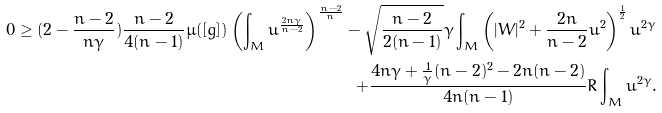Convert formula to latex. <formula><loc_0><loc_0><loc_500><loc_500>0 \geq ( 2 - \frac { n - 2 } { n \gamma } ) \frac { n - 2 } { 4 ( n - 1 ) } \mu ( [ g ] ) \left ( \int _ { M } u ^ { \frac { 2 n \gamma } { n - 2 } } \right ) ^ { \frac { n - 2 } { n } } - \sqrt { \frac { n - 2 } { 2 ( n - 1 ) } } \gamma \int _ { M } \left ( | W | ^ { 2 } + \frac { 2 n } { n - 2 } u ^ { 2 } \right ) ^ { \frac { 1 } { 2 } } u ^ { 2 \gamma } \\ + \frac { 4 n \gamma + \frac { 1 } { \gamma } ( n - 2 ) ^ { 2 } - 2 n ( n - 2 ) } { 4 n ( n - 1 ) } R \int _ { M } u ^ { 2 \gamma } .</formula> 